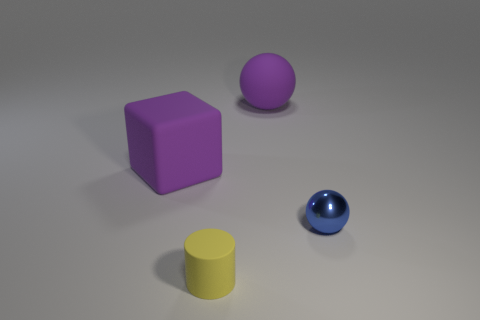Are there any other things that have the same shape as the tiny yellow matte thing?
Your response must be concise. No. Is there any other thing of the same color as the matte cylinder?
Provide a short and direct response. No. What is the small blue thing made of?
Your answer should be very brief. Metal. What number of big purple rubber balls are behind the yellow matte cylinder?
Keep it short and to the point. 1. Is the number of large purple matte things behind the purple block less than the number of big matte objects?
Your answer should be compact. Yes. The tiny matte object has what color?
Provide a short and direct response. Yellow. Is the color of the large rubber object behind the purple cube the same as the large block?
Give a very brief answer. Yes. There is another object that is the same shape as the tiny metal thing; what color is it?
Provide a succinct answer. Purple. What number of large objects are either yellow rubber cylinders or purple matte things?
Your response must be concise. 2. There is a purple thing right of the big block; what size is it?
Keep it short and to the point. Large. 